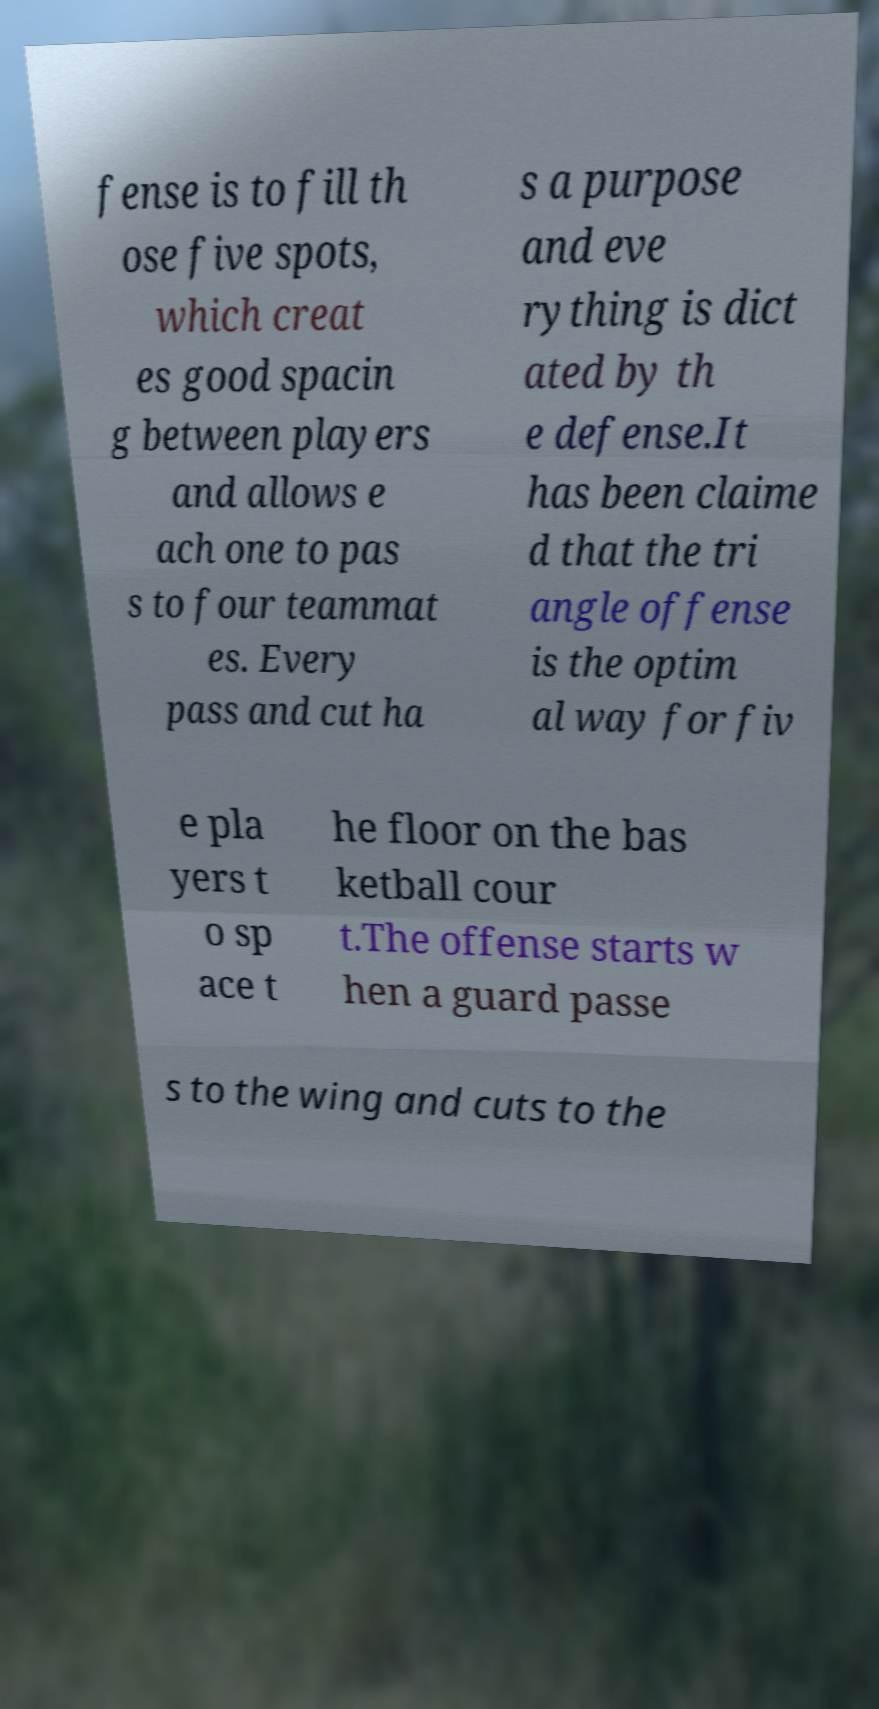Could you assist in decoding the text presented in this image and type it out clearly? fense is to fill th ose five spots, which creat es good spacin g between players and allows e ach one to pas s to four teammat es. Every pass and cut ha s a purpose and eve rything is dict ated by th e defense.It has been claime d that the tri angle offense is the optim al way for fiv e pla yers t o sp ace t he floor on the bas ketball cour t.The offense starts w hen a guard passe s to the wing and cuts to the 